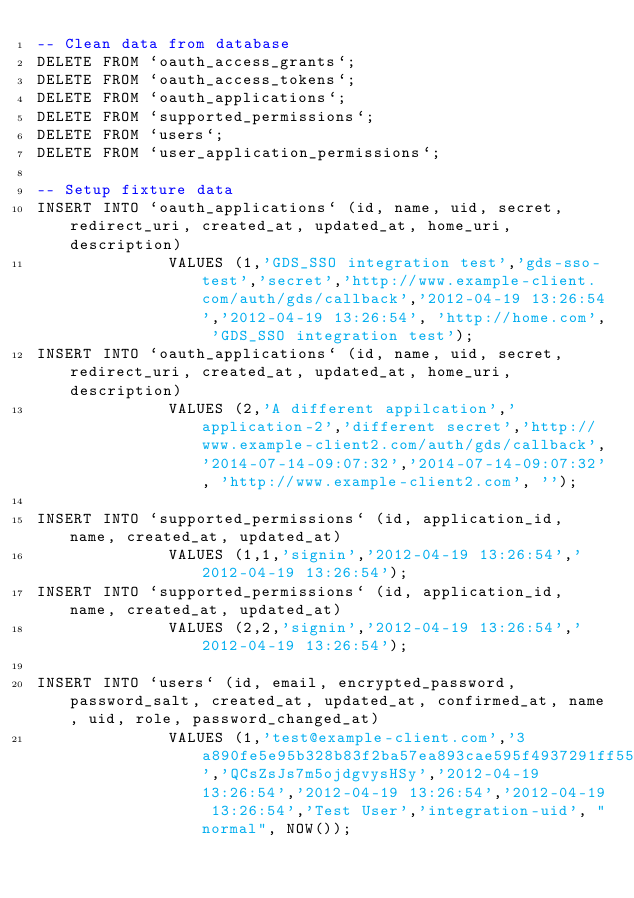Convert code to text. <code><loc_0><loc_0><loc_500><loc_500><_SQL_>-- Clean data from database
DELETE FROM `oauth_access_grants`;
DELETE FROM `oauth_access_tokens`;
DELETE FROM `oauth_applications`;
DELETE FROM `supported_permissions`;
DELETE FROM `users`;
DELETE FROM `user_application_permissions`;

-- Setup fixture data
INSERT INTO `oauth_applications` (id, name, uid, secret, redirect_uri, created_at, updated_at, home_uri, description)
              VALUES (1,'GDS_SSO integration test','gds-sso-test','secret','http://www.example-client.com/auth/gds/callback','2012-04-19 13:26:54','2012-04-19 13:26:54', 'http://home.com', 'GDS_SSO integration test');
INSERT INTO `oauth_applications` (id, name, uid, secret, redirect_uri, created_at, updated_at, home_uri, description)
              VALUES (2,'A different appilcation','application-2','different secret','http://www.example-client2.com/auth/gds/callback','2014-07-14-09:07:32','2014-07-14-09:07:32', 'http://www.example-client2.com', '');

INSERT INTO `supported_permissions` (id, application_id, name, created_at, updated_at)
              VALUES (1,1,'signin','2012-04-19 13:26:54','2012-04-19 13:26:54');
INSERT INTO `supported_permissions` (id, application_id, name, created_at, updated_at)
              VALUES (2,2,'signin','2012-04-19 13:26:54','2012-04-19 13:26:54');

INSERT INTO `users` (id, email, encrypted_password, password_salt, created_at, updated_at, confirmed_at, name, uid, role, password_changed_at)
              VALUES (1,'test@example-client.com','3a890fe5e95b328b83f2ba57ea893cae595f4937291ff5550acb68f4a8dafeac22e5f8120c1e66be8f2b769df142dd3d111b404c5c1741595c9ecc9e7e6ad827','QCsZsJs7m5ojdgvysHSy','2012-04-19 13:26:54','2012-04-19 13:26:54','2012-04-19 13:26:54','Test User','integration-uid', "normal", NOW());
</code> 